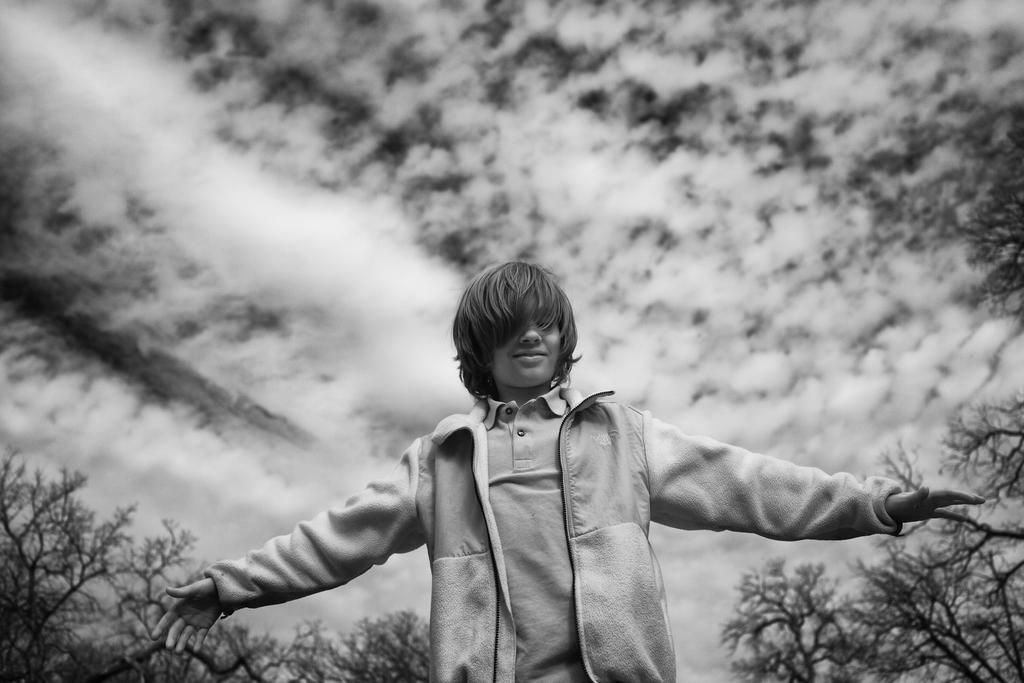Who or what is present in the image? There is a person in the image. What is the person's facial expression? The person is smiling. What can be seen in the background of the image? There are trees and the sky visible in the background of the image. What is the condition of the sky in the image? Clouds are present in the sky. Can you see a line of bees flying across the sky in the image? No, there are no bees or lines of bees visible in the image. 